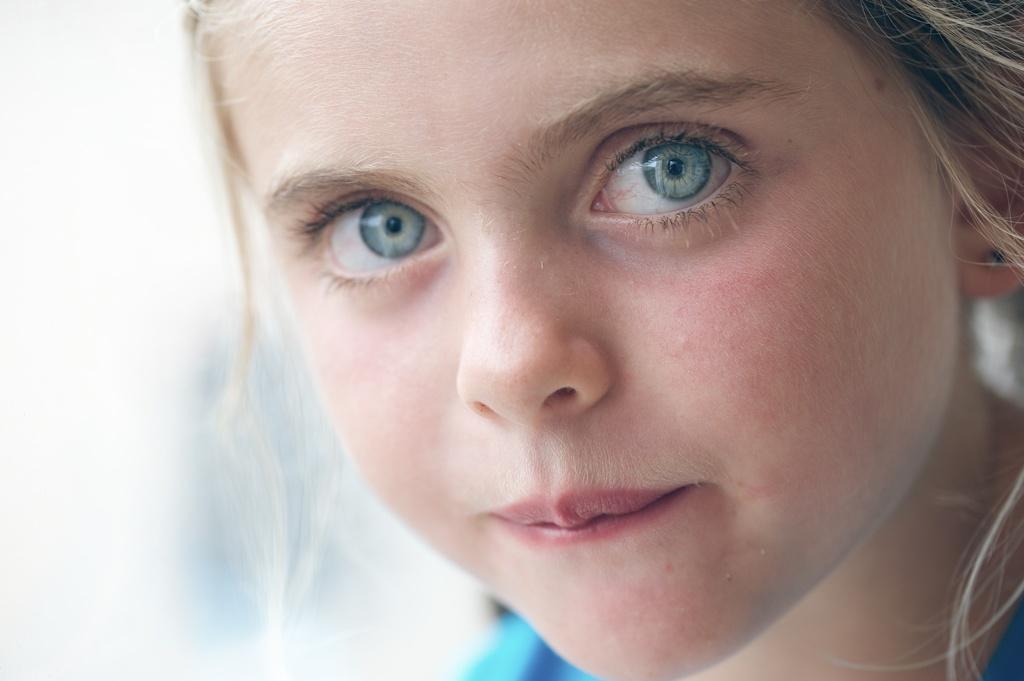In one or two sentences, can you explain what this image depicts? In this image, I can see the face of a girl. There is a blurred background. 